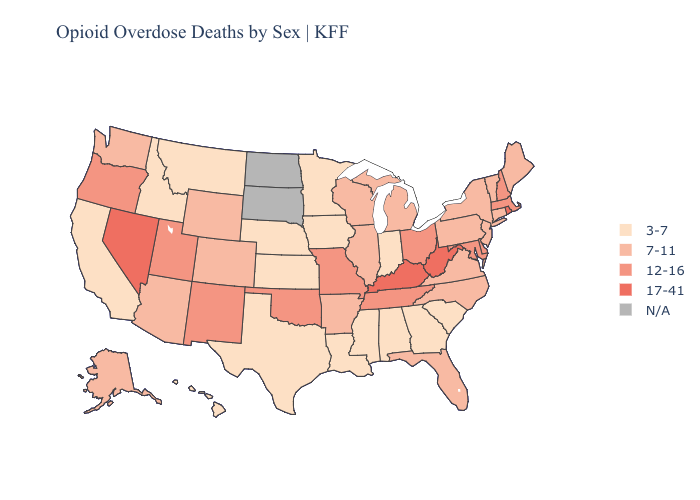What is the lowest value in the USA?
Short answer required. 3-7. What is the value of Utah?
Write a very short answer. 12-16. Name the states that have a value in the range 17-41?
Concise answer only. Kentucky, Nevada, Rhode Island, West Virginia. Name the states that have a value in the range 7-11?
Concise answer only. Alaska, Arizona, Arkansas, Colorado, Connecticut, Florida, Illinois, Maine, Michigan, New Jersey, New York, North Carolina, Pennsylvania, Vermont, Virginia, Washington, Wisconsin, Wyoming. What is the value of Nebraska?
Keep it brief. 3-7. Does Kentucky have the highest value in the USA?
Be succinct. Yes. Does Kentucky have the highest value in the USA?
Give a very brief answer. Yes. Does West Virginia have the highest value in the South?
Answer briefly. Yes. Name the states that have a value in the range 17-41?
Concise answer only. Kentucky, Nevada, Rhode Island, West Virginia. What is the highest value in the Northeast ?
Keep it brief. 17-41. What is the value of Wisconsin?
Answer briefly. 7-11. What is the value of Georgia?
Give a very brief answer. 3-7. 